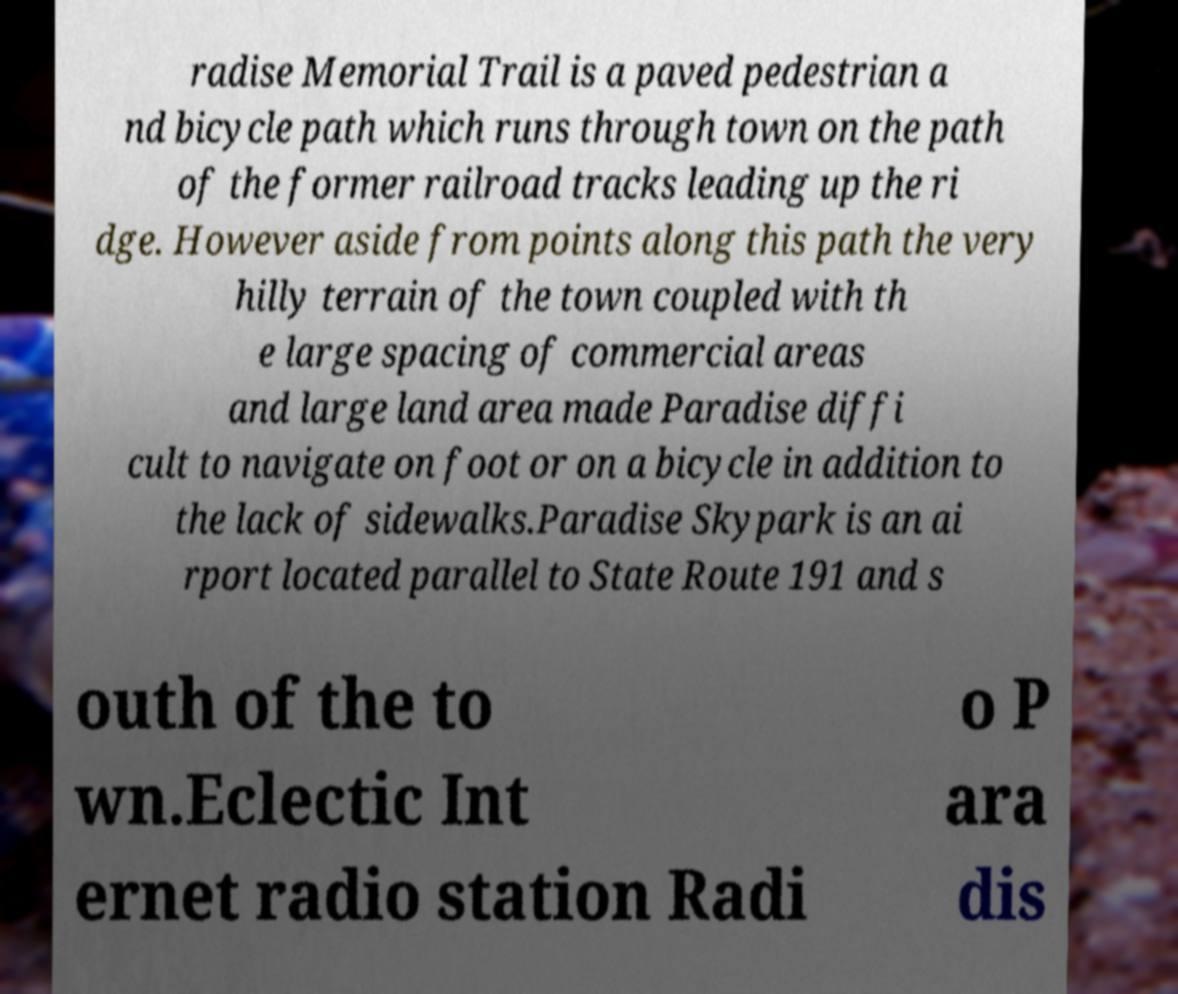Please read and relay the text visible in this image. What does it say? radise Memorial Trail is a paved pedestrian a nd bicycle path which runs through town on the path of the former railroad tracks leading up the ri dge. However aside from points along this path the very hilly terrain of the town coupled with th e large spacing of commercial areas and large land area made Paradise diffi cult to navigate on foot or on a bicycle in addition to the lack of sidewalks.Paradise Skypark is an ai rport located parallel to State Route 191 and s outh of the to wn.Eclectic Int ernet radio station Radi o P ara dis 